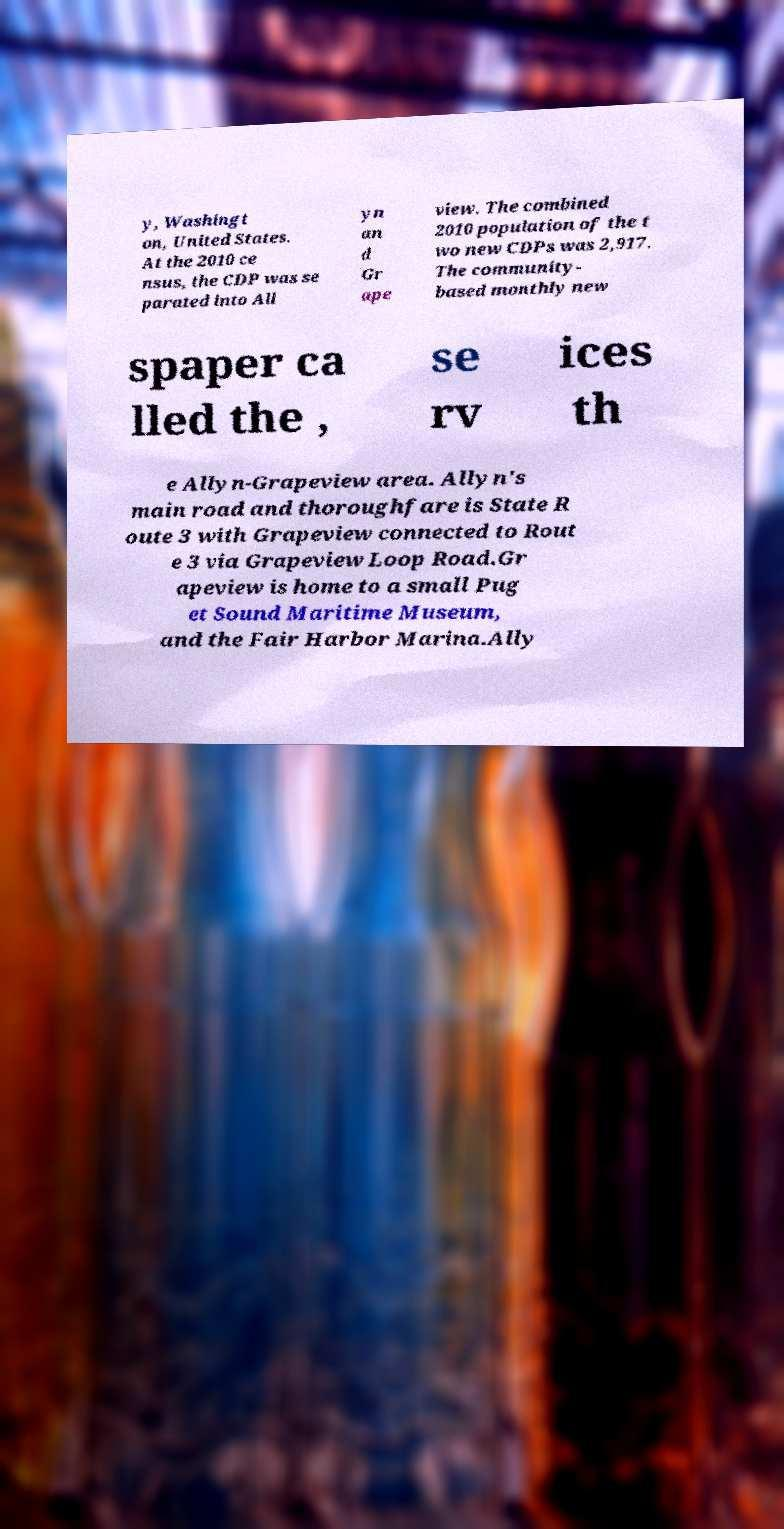I need the written content from this picture converted into text. Can you do that? y, Washingt on, United States. At the 2010 ce nsus, the CDP was se parated into All yn an d Gr ape view. The combined 2010 population of the t wo new CDPs was 2,917. The community- based monthly new spaper ca lled the , se rv ices th e Allyn-Grapeview area. Allyn's main road and thoroughfare is State R oute 3 with Grapeview connected to Rout e 3 via Grapeview Loop Road.Gr apeview is home to a small Pug et Sound Maritime Museum, and the Fair Harbor Marina.Ally 